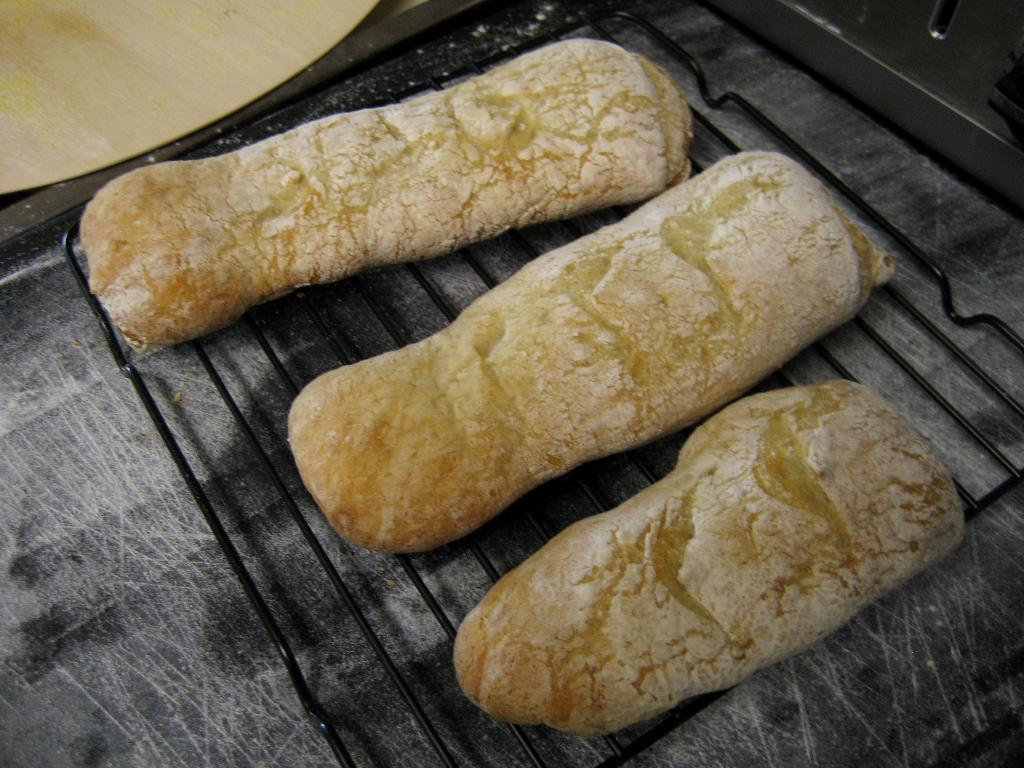What is the main object on the table in the image? There is a grill on a table in the image. Who is present in the image? There is a girl in the image. What can be seen besides the girl and the grill? There is a food item in the image. What type of harmony is being played on the sofa in the image? There is no sofa or harmony present in the image. 